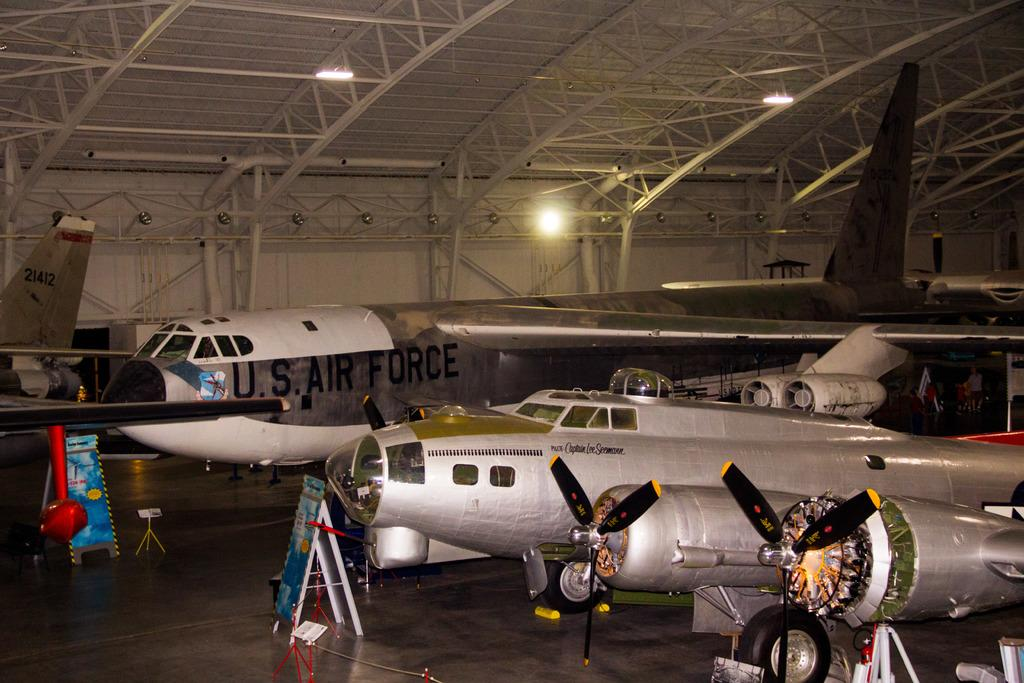Provide a one-sentence caption for the provided image. A large U.S. Air Force jet sits in a hanger. 